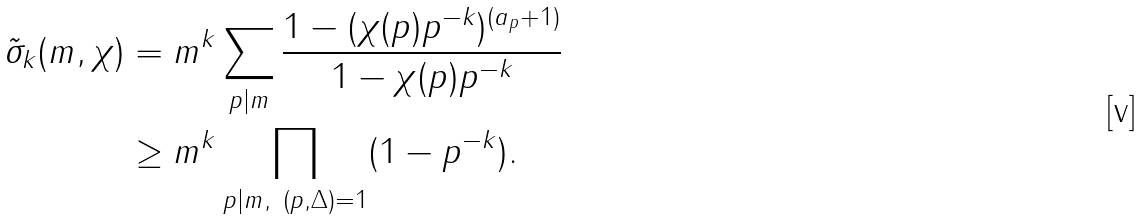Convert formula to latex. <formula><loc_0><loc_0><loc_500><loc_500>\tilde { \sigma } _ { k } ( m , \chi ) & = m ^ { k } \sum _ { p | m } \frac { 1 - ( \chi ( p ) p ^ { - k } ) ^ { ( a _ { p } + 1 ) } } { 1 - \chi ( p ) p ^ { - k } } \\ & \geq m ^ { k } \prod _ { p | m , \ ( p , \Delta ) = 1 } ( 1 - p ^ { - k } ) .</formula> 